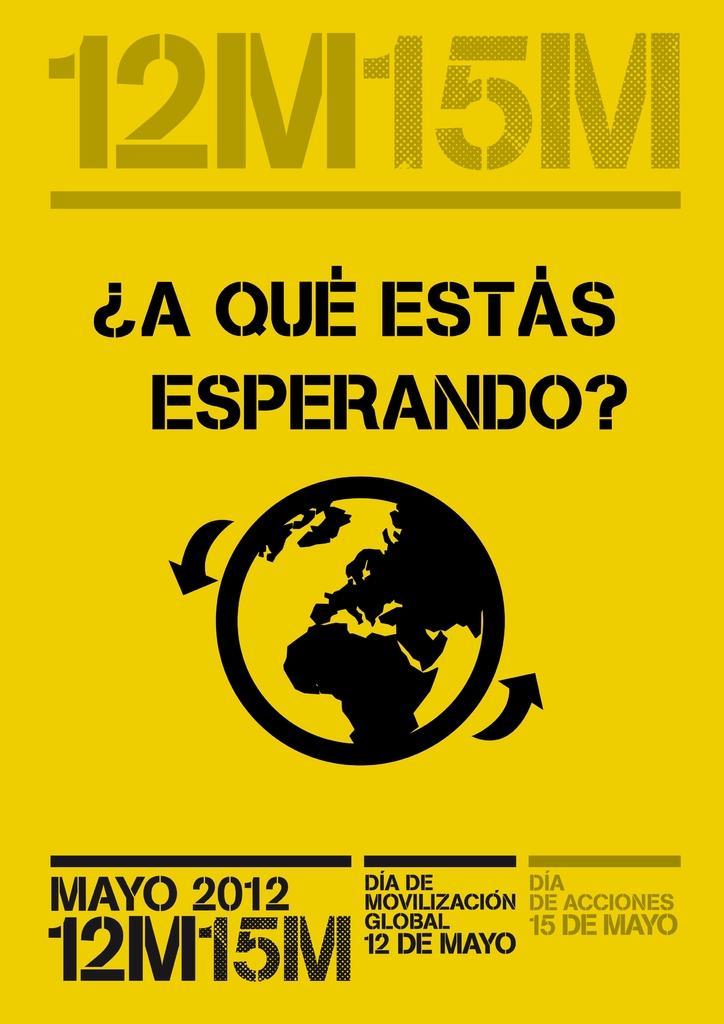Can you describe this image briefly? In the image there is a yellow poster with an icon and text above and below it. 